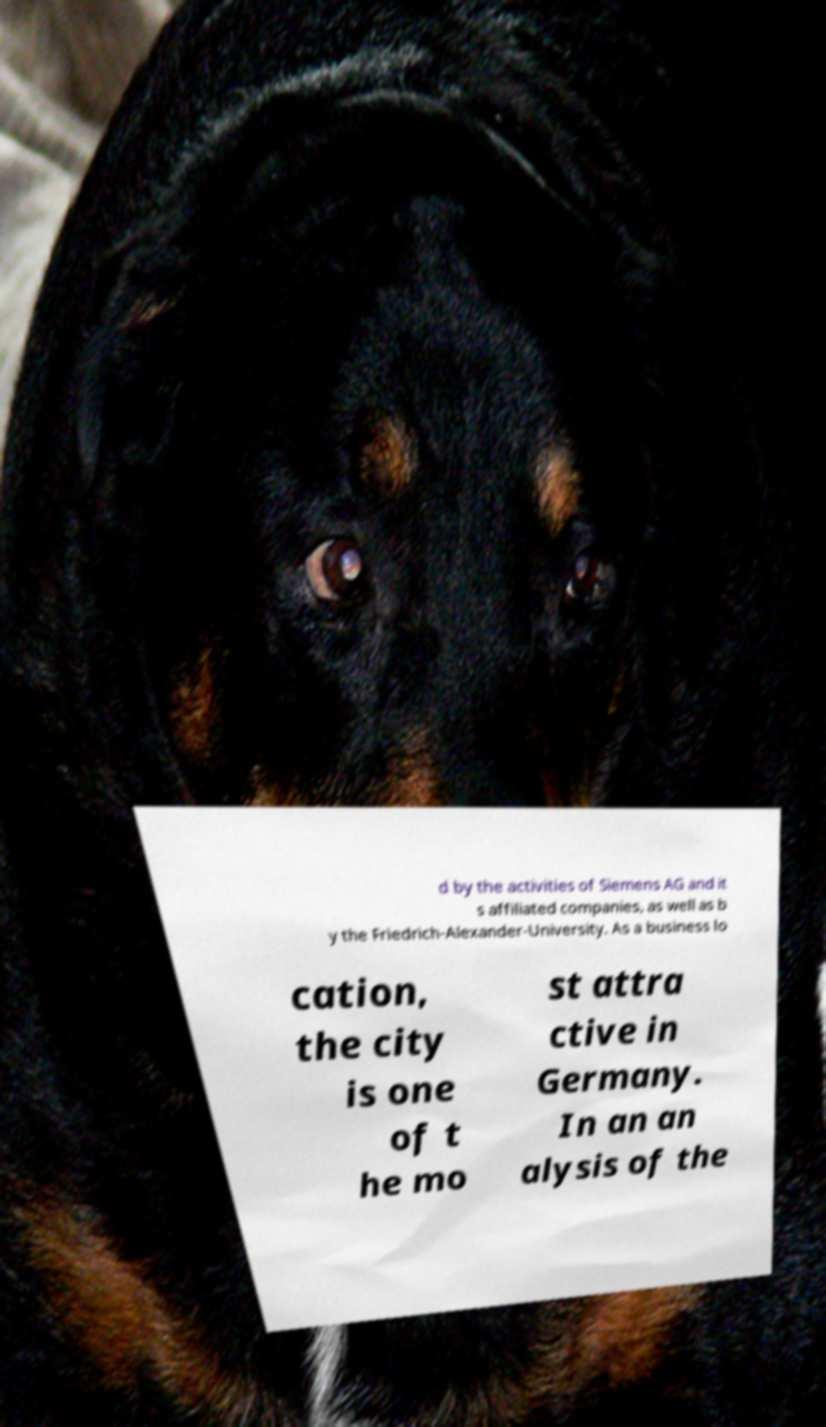Can you accurately transcribe the text from the provided image for me? d by the activities of Siemens AG and it s affiliated companies, as well as b y the Friedrich-Alexander-University. As a business lo cation, the city is one of t he mo st attra ctive in Germany. In an an alysis of the 